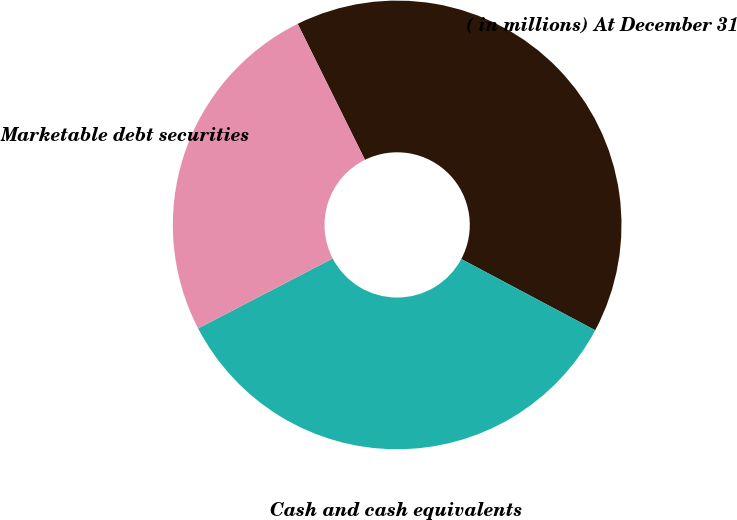Convert chart. <chart><loc_0><loc_0><loc_500><loc_500><pie_chart><fcel>( in millions) At December 31<fcel>Cash and cash equivalents<fcel>Marketable debt securities<nl><fcel>40.09%<fcel>34.59%<fcel>25.32%<nl></chart> 